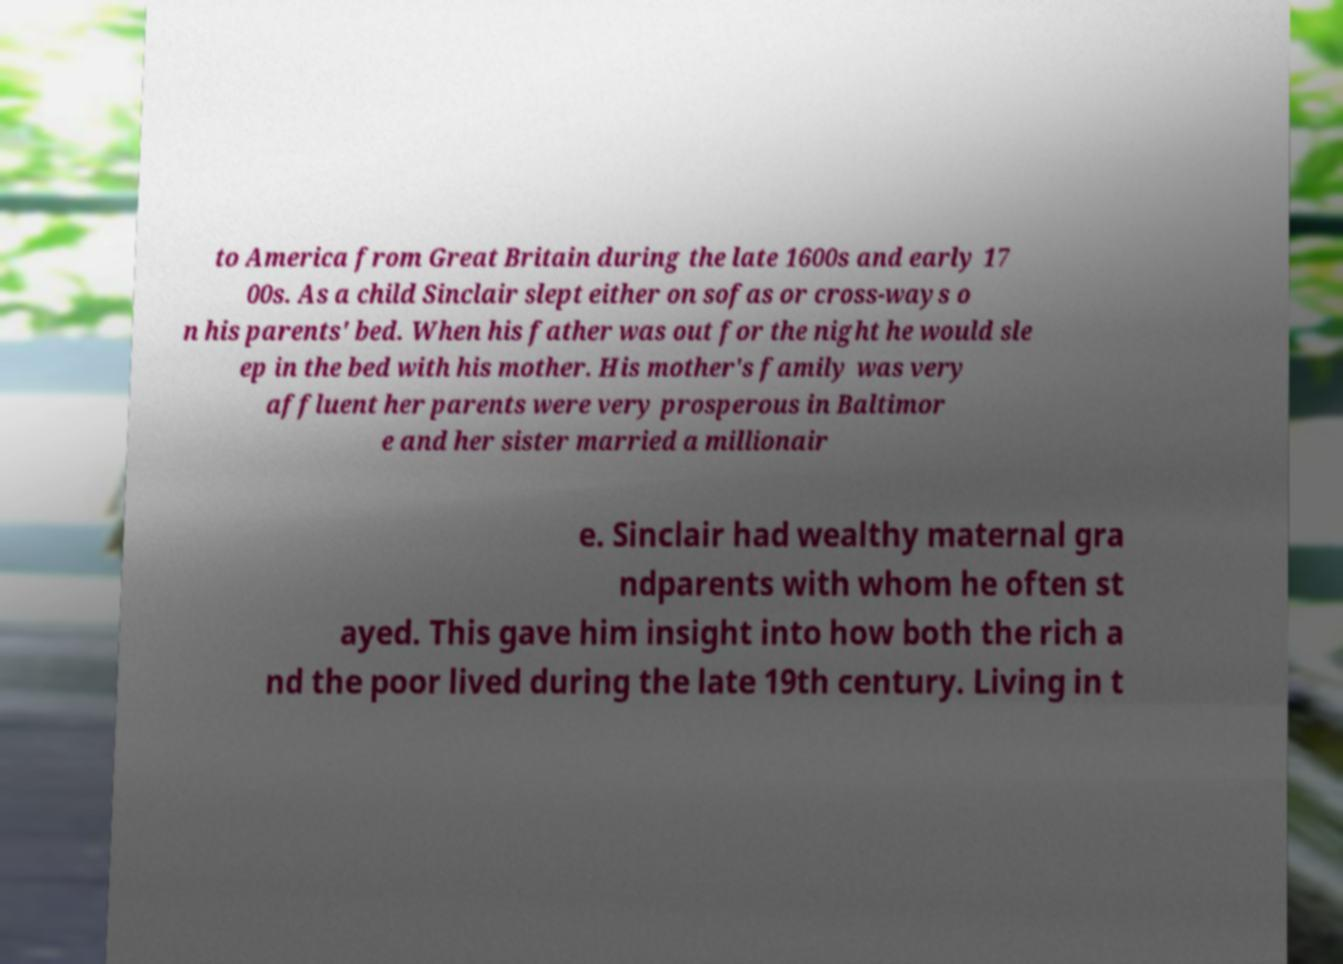What messages or text are displayed in this image? I need them in a readable, typed format. to America from Great Britain during the late 1600s and early 17 00s. As a child Sinclair slept either on sofas or cross-ways o n his parents' bed. When his father was out for the night he would sle ep in the bed with his mother. His mother's family was very affluent her parents were very prosperous in Baltimor e and her sister married a millionair e. Sinclair had wealthy maternal gra ndparents with whom he often st ayed. This gave him insight into how both the rich a nd the poor lived during the late 19th century. Living in t 